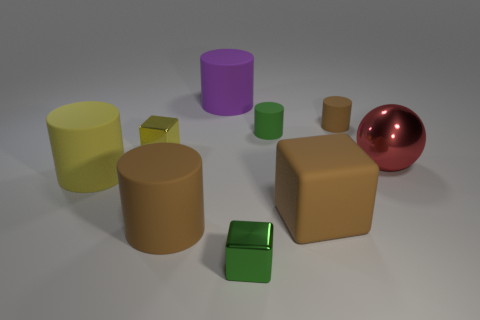Is the brown thing that is to the left of the purple matte object made of the same material as the large cube?
Provide a succinct answer. Yes. What number of other things are there of the same material as the tiny brown cylinder
Offer a terse response. 5. What is the tiny brown object made of?
Your answer should be compact. Rubber. There is a brown cylinder in front of the tiny yellow cube; what size is it?
Keep it short and to the point. Large. There is a tiny cylinder that is in front of the small brown thing; how many brown matte cylinders are on the left side of it?
Keep it short and to the point. 1. There is a yellow metal thing in front of the big purple rubber cylinder; does it have the same shape as the tiny thing that is in front of the yellow metal thing?
Provide a succinct answer. Yes. What number of metallic things are both behind the big red ball and on the right side of the tiny brown cylinder?
Provide a succinct answer. 0. Are there any big things that have the same color as the large matte block?
Offer a terse response. Yes. What shape is the purple thing that is the same size as the ball?
Keep it short and to the point. Cylinder. There is a large yellow matte cylinder; are there any yellow objects to the right of it?
Offer a very short reply. Yes. 